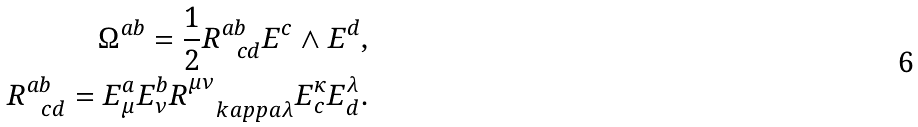<formula> <loc_0><loc_0><loc_500><loc_500>\Omega ^ { a b } = \frac { 1 } { 2 } R ^ { a b } _ { \ \ c d } E ^ { c } \wedge E ^ { d } , \\ R ^ { a b } _ { \ \ c d } = E ^ { a } _ { \mu } E ^ { b } _ { \nu } R ^ { \mu \nu } _ { \quad k a p p a \lambda } E ^ { \kappa } _ { c } E ^ { \lambda } _ { d } .</formula> 